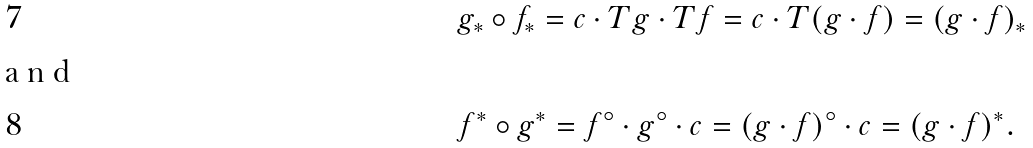<formula> <loc_0><loc_0><loc_500><loc_500>& g _ { * } \circ f _ { * } = c \cdot T g \cdot T f = c \cdot T ( g \cdot f ) = ( g \cdot f ) _ { * } \\ \intertext { a n d } & f ^ { * } \circ g ^ { * } = f ^ { \circ } \cdot g ^ { \circ } \cdot c = ( g \cdot f ) ^ { \circ } \cdot c = ( g \cdot f ) ^ { * } .</formula> 